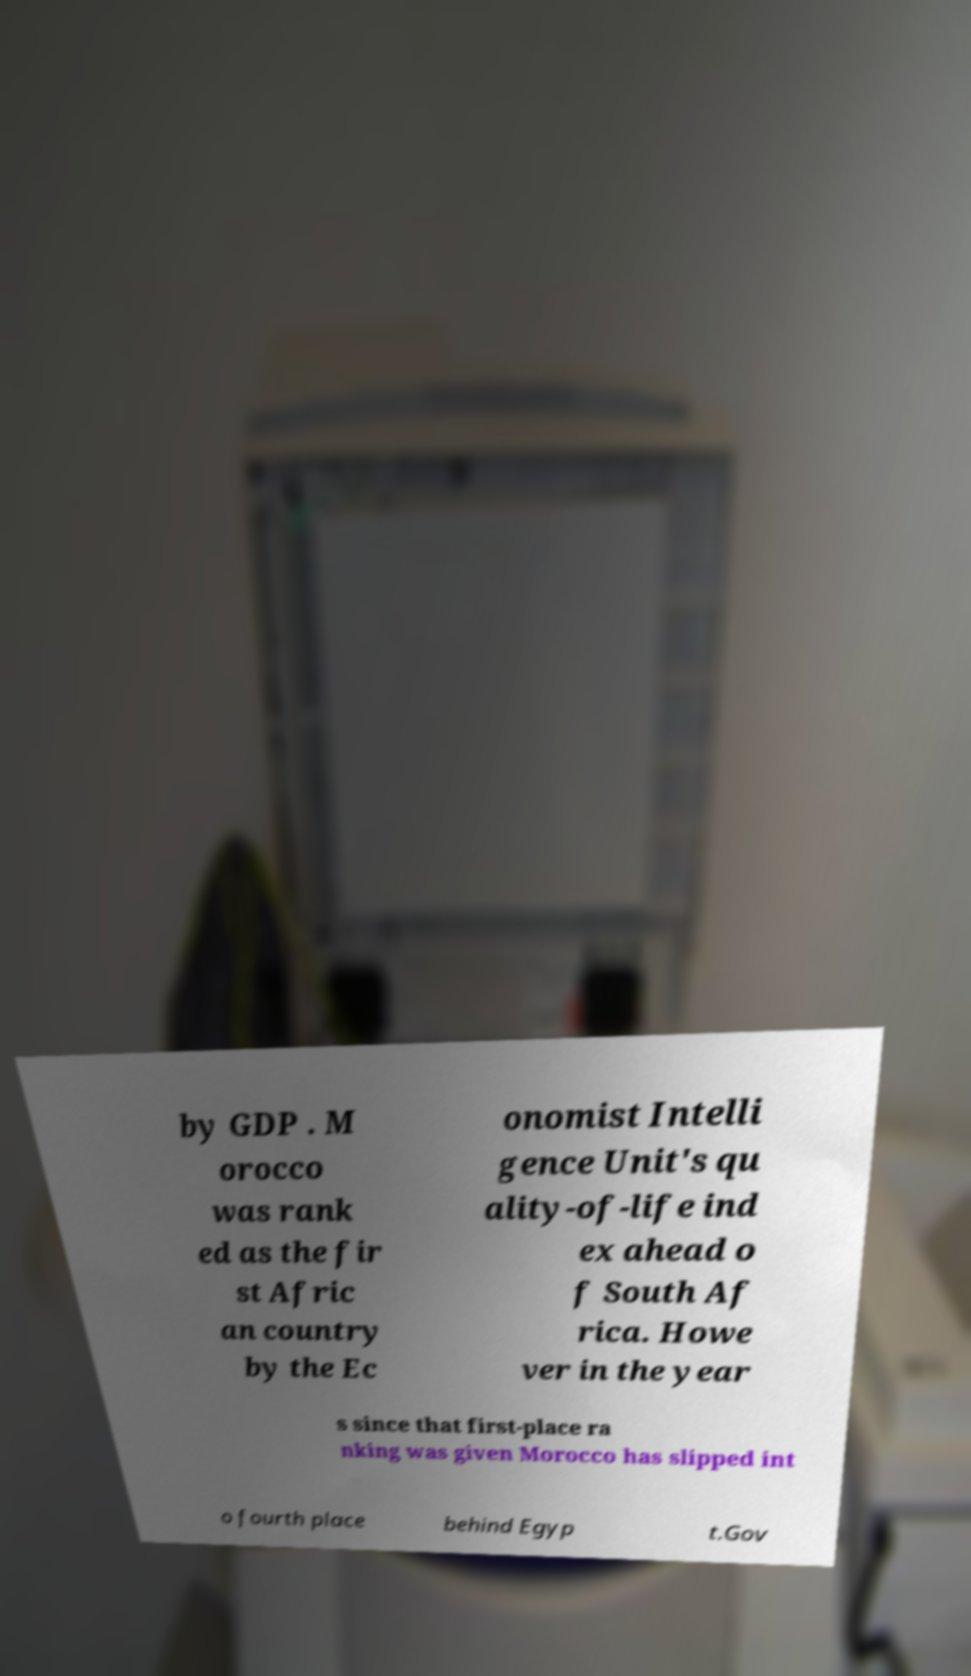There's text embedded in this image that I need extracted. Can you transcribe it verbatim? by GDP . M orocco was rank ed as the fir st Afric an country by the Ec onomist Intelli gence Unit's qu ality-of-life ind ex ahead o f South Af rica. Howe ver in the year s since that first-place ra nking was given Morocco has slipped int o fourth place behind Egyp t.Gov 